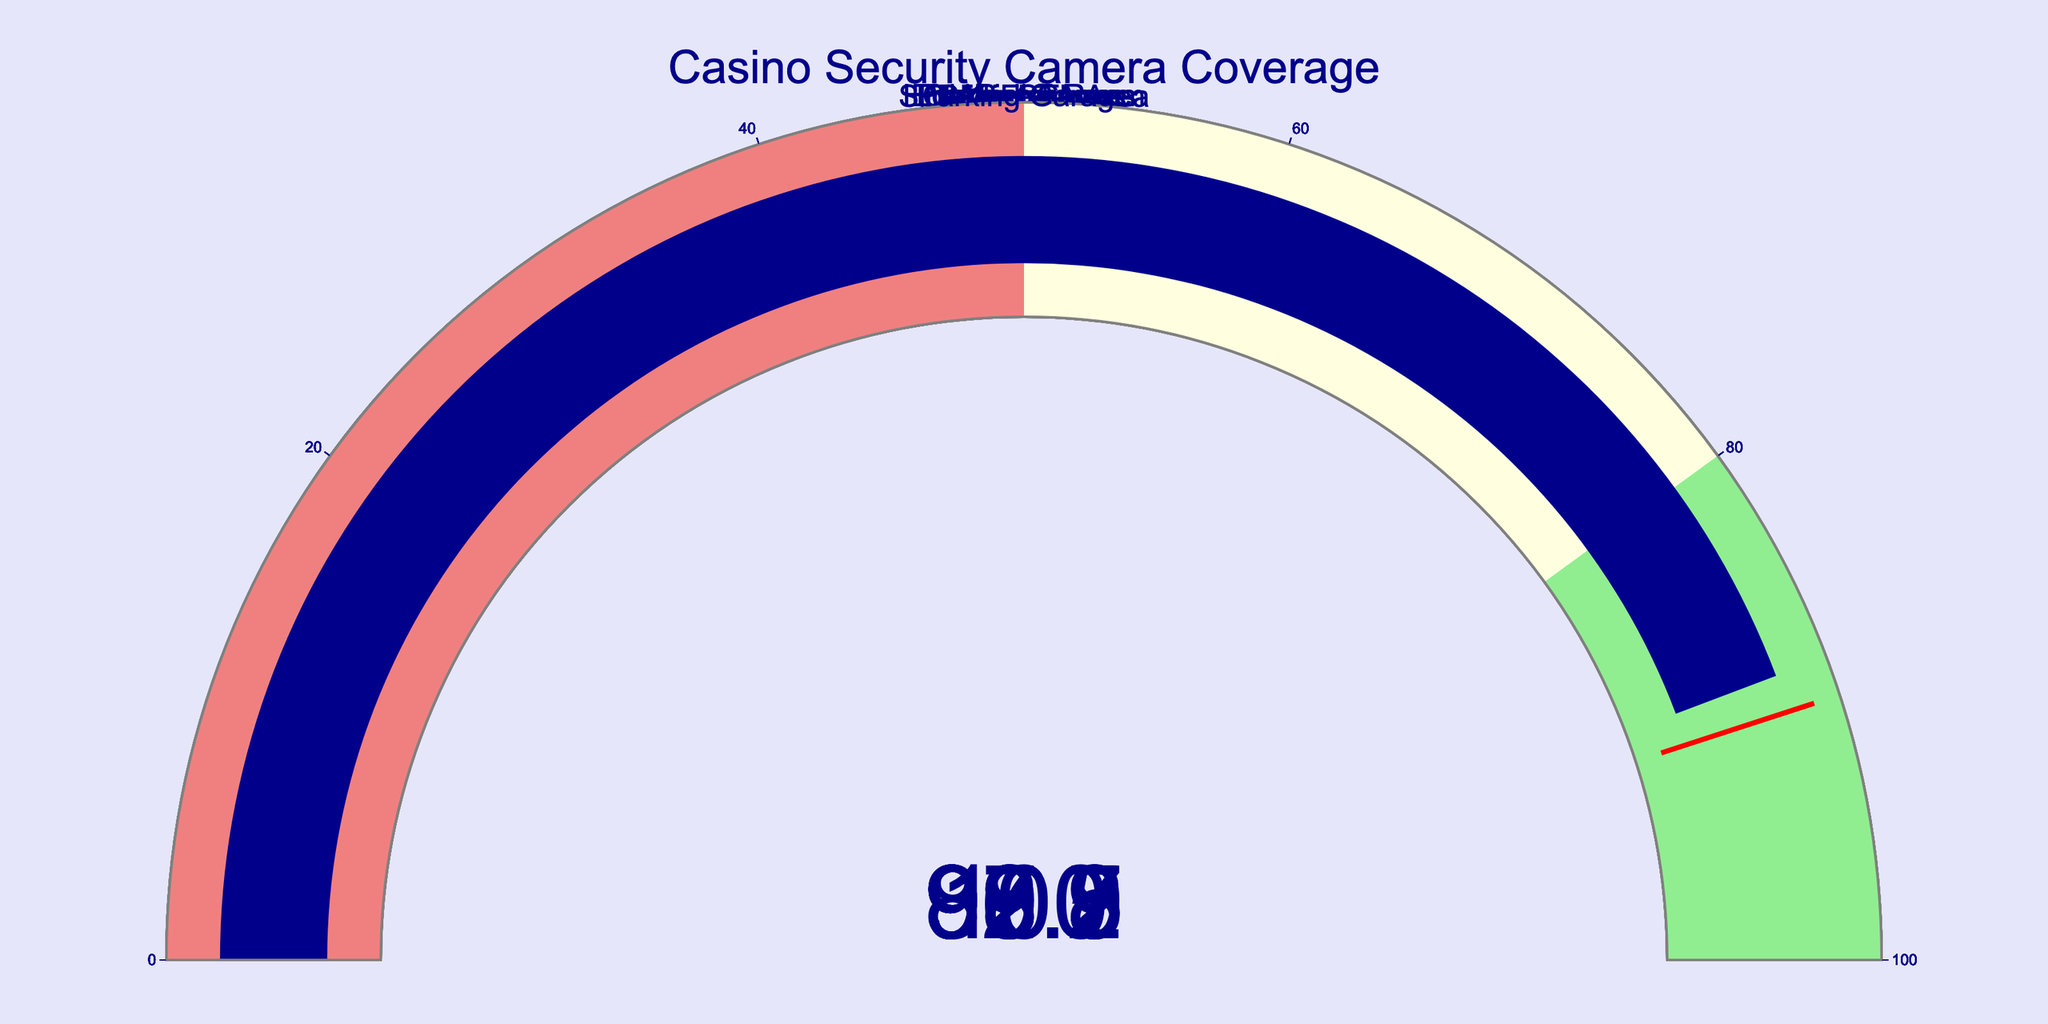What's the security camera coverage percentage of the High Roller Room? Look at the gauge corresponding to "High Roller Room" in the figure to find the coverage percentage.
Answer: 100 Which area has the lowest camera coverage? Compare all the gauge values and identify the minimum coverage percentage. The lowest value is found in the "Parking Garage."
Answer: Parking Garage Is the camera coverage of the Slot Machine Area higher than the Casino Floor? Compare the gauge values for "Slot Machine Area" and "Casino Floor." The Slot Machine Area has 99.2%, and the Casino Floor has 98.5%.
Answer: Yes What is the average camera coverage percentage of the Cashier Cages and Main Entrance? Find the values for "Cashier Cages" (99.9%) and "Main Entrance" (96.3%), and calculate their average: (99.9 + 96.3) / 2 = 98.1.
Answer: 98.1 How many areas have a coverage percentage above 90%? Count the number of gauges with values over 90%. These areas are: Casino Floor, Slot Machine Area, Table Games, High Roller Room, Cashier Cages, Main Entrance, and Employee Areas (7 areas).
Answer: 7 Which area has a higher camera coverage, the Employee Areas or the Parking Garage? Compare the gauge values for "Employee Areas" (92.7%) and "Parking Garage" (88.5%).
Answer: Employee Areas What's the median coverage percentage among all the areas? List out all coverage percentages in ascending order: 88.5, 92.7, 96.3, 97.8, 98.5, 99.2, 99.9, 100. The median is the average of the two middle values, (97.8 + 98.5) / 2 = 98.15.
Answer: 98.15 Are there any areas with 100% camera coverage? Identify if any of the gauges read 100%. The "High Roller Room" has 100% coverage.
Answer: Yes What's the difference in camera coverage between the Main Entrance and the Parking Garage? Subtract the coverage percentage of the Parking Garage (88.5%) from the Main Entrance (96.3%): 96.3 - 88.5 = 7.8.
Answer: 7.8 Which area has a camera coverage closest to 99%? Identify the gauge whose value is closest to 99%. The "Slot Machine Area" has a value of 99.2%, which is closest.
Answer: Slot Machine Area 